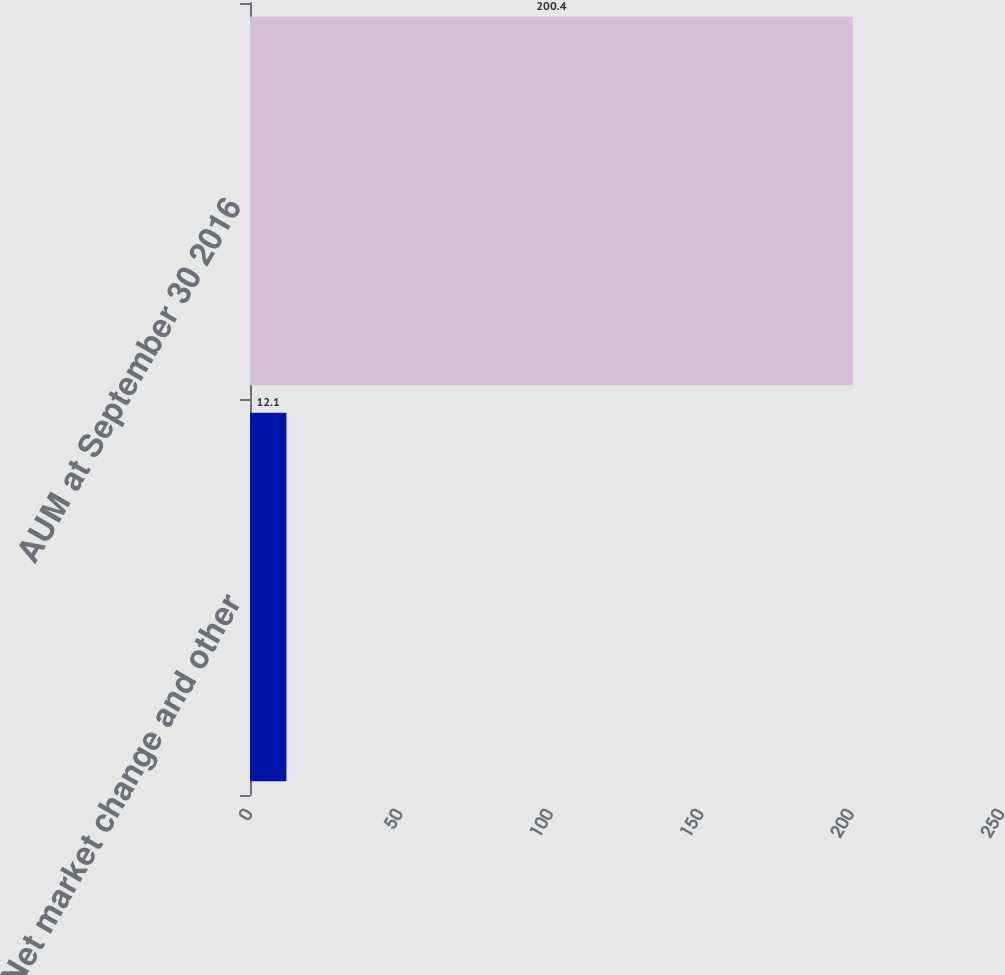Convert chart. <chart><loc_0><loc_0><loc_500><loc_500><bar_chart><fcel>Net market change and other<fcel>AUM at September 30 2016<nl><fcel>12.1<fcel>200.4<nl></chart> 